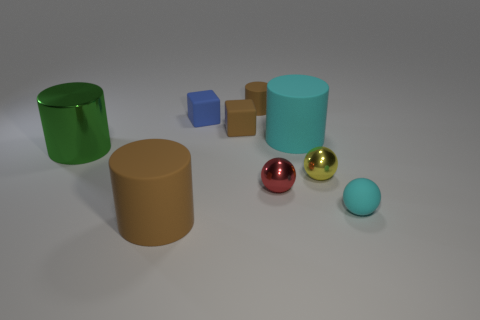Add 1 tiny green spheres. How many objects exist? 10 Subtract all cubes. How many objects are left? 7 Subtract all tiny brown balls. Subtract all cyan cylinders. How many objects are left? 8 Add 7 matte blocks. How many matte blocks are left? 9 Add 4 tiny metallic cylinders. How many tiny metallic cylinders exist? 4 Subtract 1 brown blocks. How many objects are left? 8 